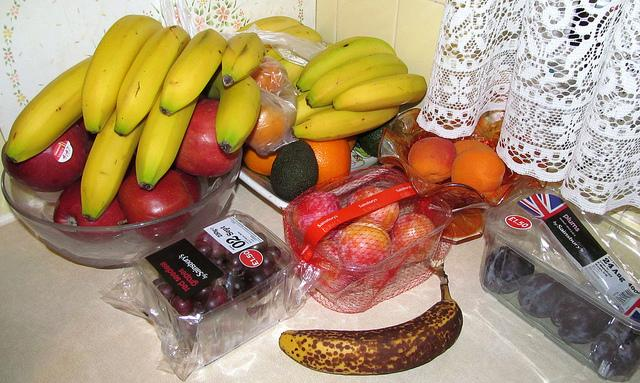What color is the banana without a bunch on the countertop directly?

Choices:
A) brown
B) black
C) yellow
D) green brown 